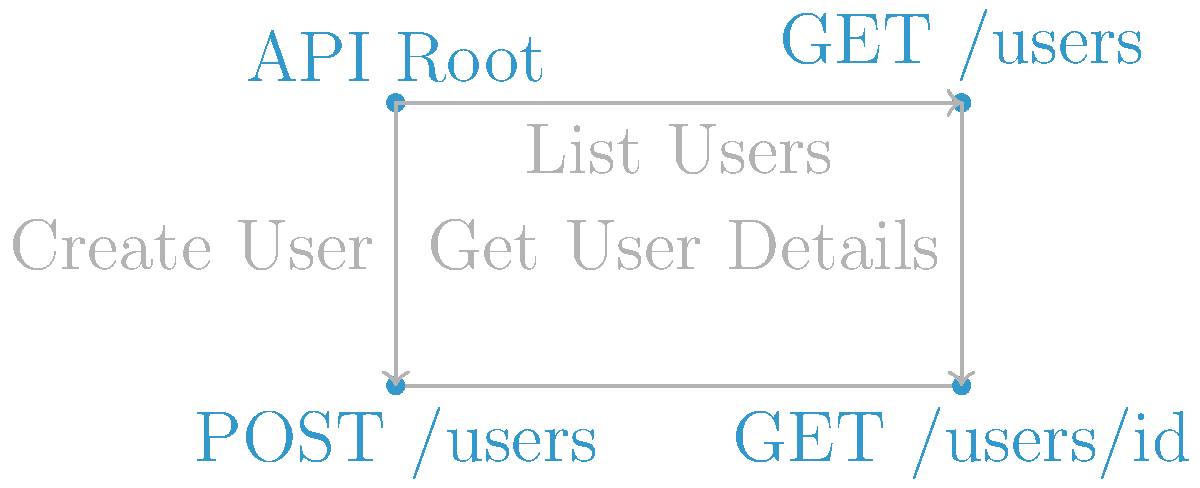In the Swagger API documentation diagram above, which endpoint would you use to retrieve information about a specific user, and what HTTP method does it employ? To answer this question, let's break down the information provided in the diagram:

1. We can see four endpoints represented by dots in the diagram:
   - API Root
   - GET /users
   - POST /users
   - GET /users/{id}

2. Each endpoint is associated with a specific action:
   - "List Users" connects API Root to GET /users
   - "Create User" connects API Root to POST /users
   - "Get User Details" connects GET /users to GET /users/{id}

3. To retrieve information about a specific user, we need an endpoint that:
   a) Deals with individual users
   b) Retrieves (gets) information rather than creates or modifies it

4. The endpoint GET /users/{id} satisfies both these criteria:
   - It includes {id}, which suggests it deals with a specific user
   - It uses the GET HTTP method, which is typically used for retrieving information

5. The "Get User Details" action pointing to this endpoint further confirms that this is the correct choice for retrieving information about a specific user.

Therefore, the endpoint to retrieve information about a specific user is GET /users/{id}, which employs the GET HTTP method.
Answer: GET /users/{id} 